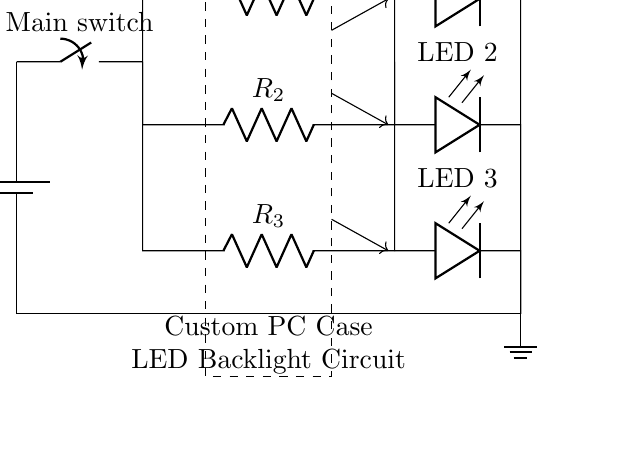What is the source voltage in the circuit? The source voltage is indicated next to the battery symbol, which is labeled as 12 V.
Answer: 12 V What components are connected in parallel in this circuit? The components connected in parallel are the three resistors labeled R1, R2, and R3, along with the three LEDs. Each of these branches connects to the same two nodes at the top and bottom, allowing them to operate independently.
Answer: R1, R2, R3, LED 1, LED 2, LED 3 Which component controls the LED lighting? The component that controls the LED lighting is labeled as the LED Controller, which is represented by a dashed rectangle in the diagram.
Answer: LED Controller If one LED fails, what happens to the others? If one LED fails, the others will still operate since they are in parallel. This means that the current can still flow through the other branches, allowing the remaining LEDs to light up.
Answer: They still operate How many resistors are in the circuit? There are three resistors in the circuit, labeled R1, R2, and R3, which serve to limit the current through the LEDs.
Answer: 3 What type of circuit is depicted in the diagram? The circuit depicted in the diagram is a parallel circuit, where multiple components are connected across the same voltage source and share the same two connection points.
Answer: Parallel circuit 